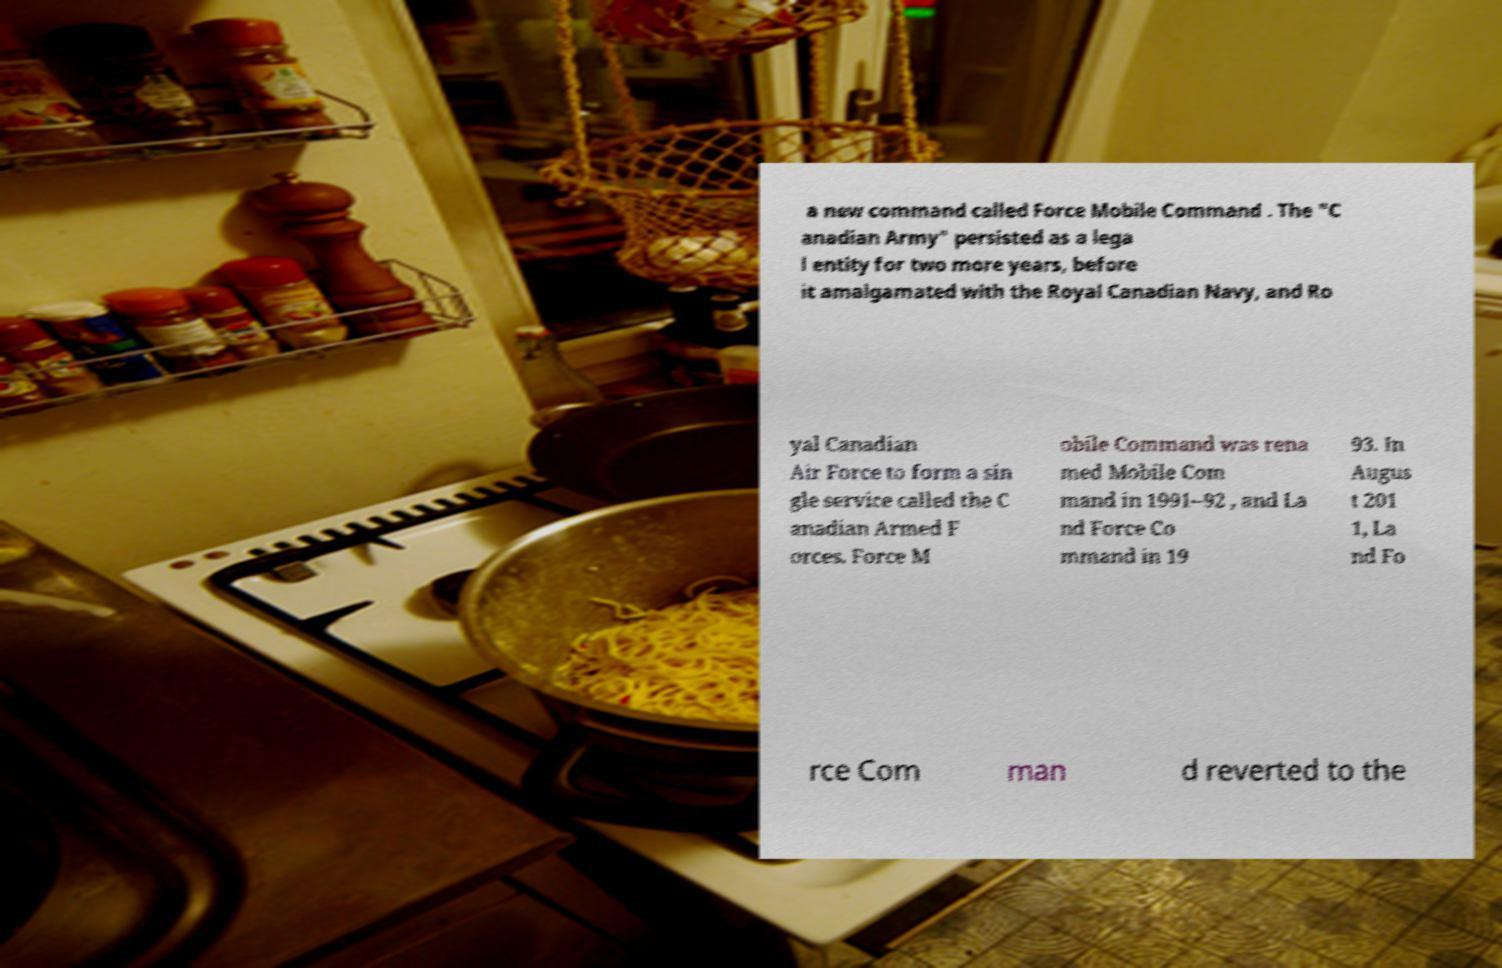Can you accurately transcribe the text from the provided image for me? a new command called Force Mobile Command . The "C anadian Army" persisted as a lega l entity for two more years, before it amalgamated with the Royal Canadian Navy, and Ro yal Canadian Air Force to form a sin gle service called the C anadian Armed F orces. Force M obile Command was rena med Mobile Com mand in 1991–92 , and La nd Force Co mmand in 19 93. In Augus t 201 1, La nd Fo rce Com man d reverted to the 